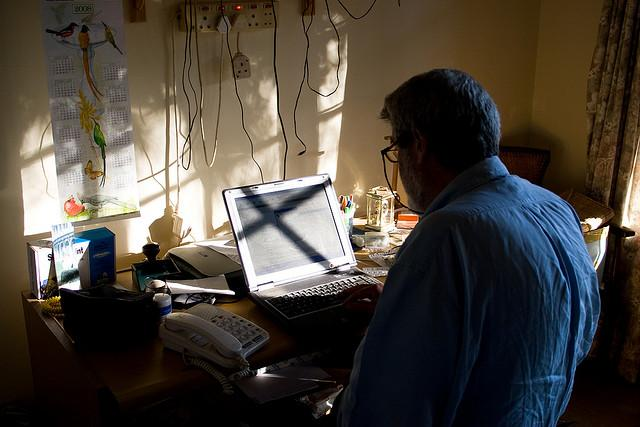What is the man using the computer to do? Please explain your reasoning. type. The man is typing. 